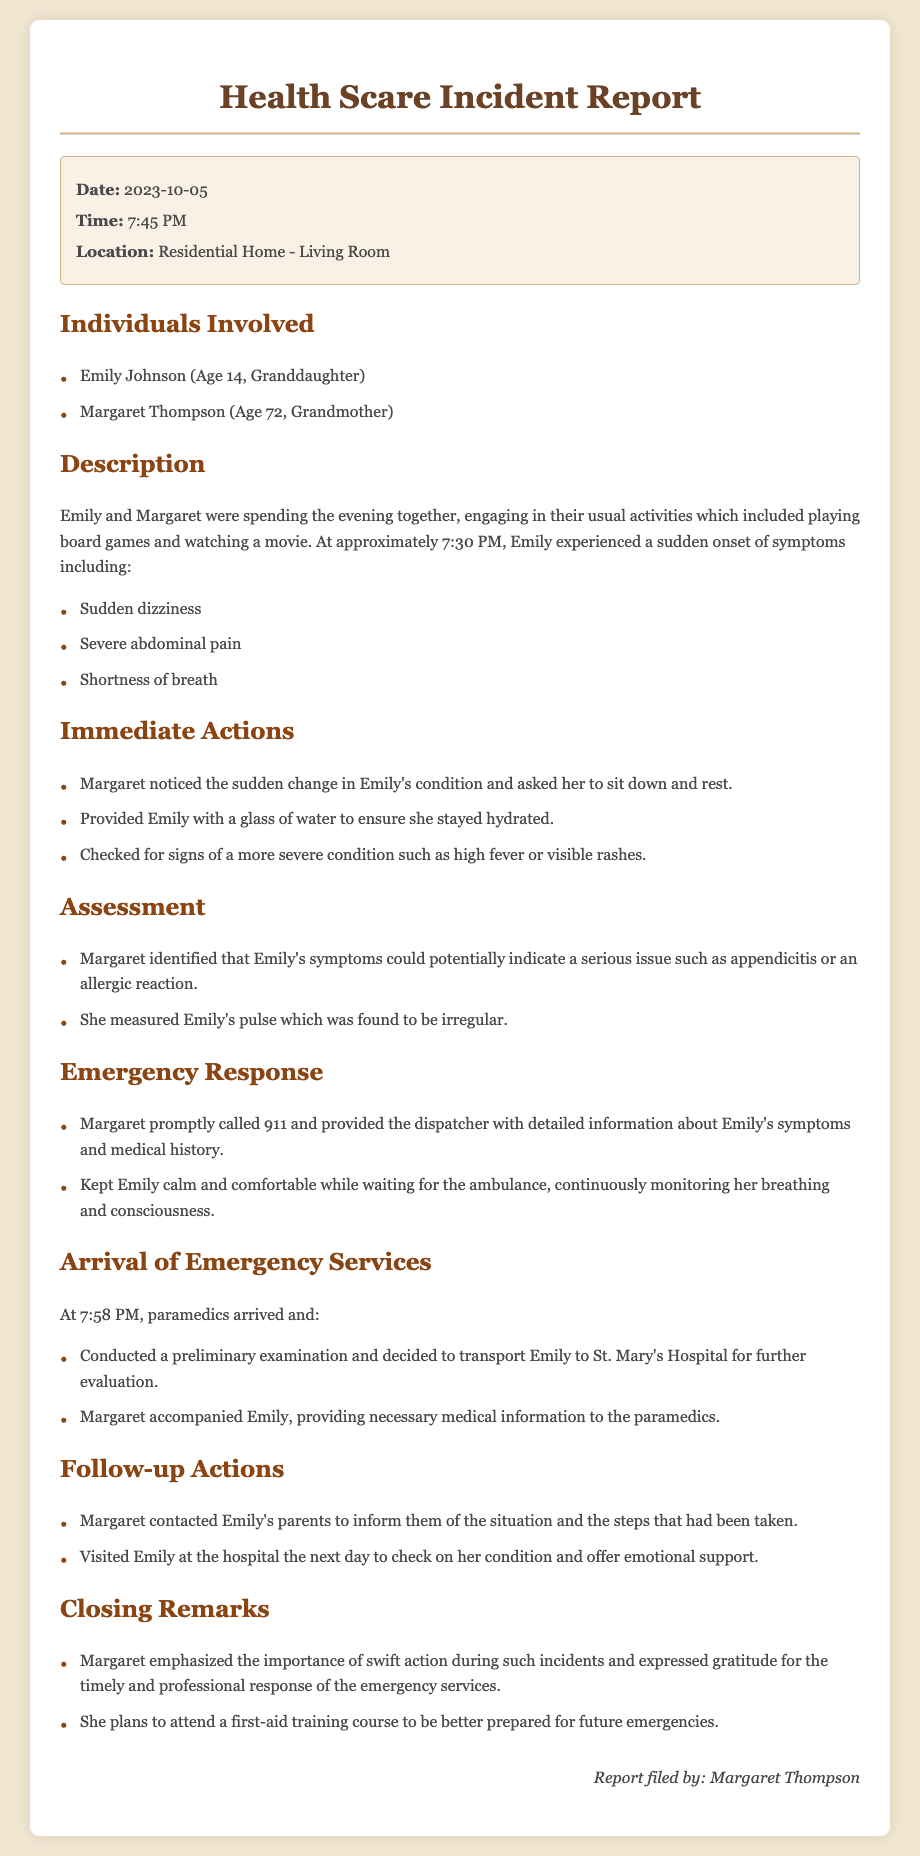What date did the incident occur? The date of the incident is specified in the document header under 'Date'.
Answer: 2023-10-05 What were Emily's symptoms? The document lists Emily's symptoms in the description section, including dizziness, abdominal pain, and shortness of breath.
Answer: Dizziness, abdominal pain, shortness of breath What time did the ambulance arrive? The arrival time of the ambulance is noted in the section for 'Arrival of Emergency Services' as 7:58 PM.
Answer: 7:58 PM Who accompanied Emily to the hospital? The document states that Margaret accompanied Emily during her transport to the hospital.
Answer: Margaret What was the immediate action taken by Margaret? The immediate actions taken by Margaret are listed in the 'Immediate Actions' section.
Answer: Asked her to sit down and rest Why did Margaret contact Emily's parents? The reason is provided in the 'Follow-up Actions' section, where it mentions informing them of the situation.
Answer: To inform them of the situation How did Margaret assess Emily's condition? The assessment of Emily's condition is described in the 'Assessment' section, primarily through observing symptoms and measuring pulse.
Answer: Measured Emily's pulse What course does Margaret plan to attend? The document mentions Margaret's plans for a specific training in the 'Closing Remarks' section.
Answer: First-aid training course 